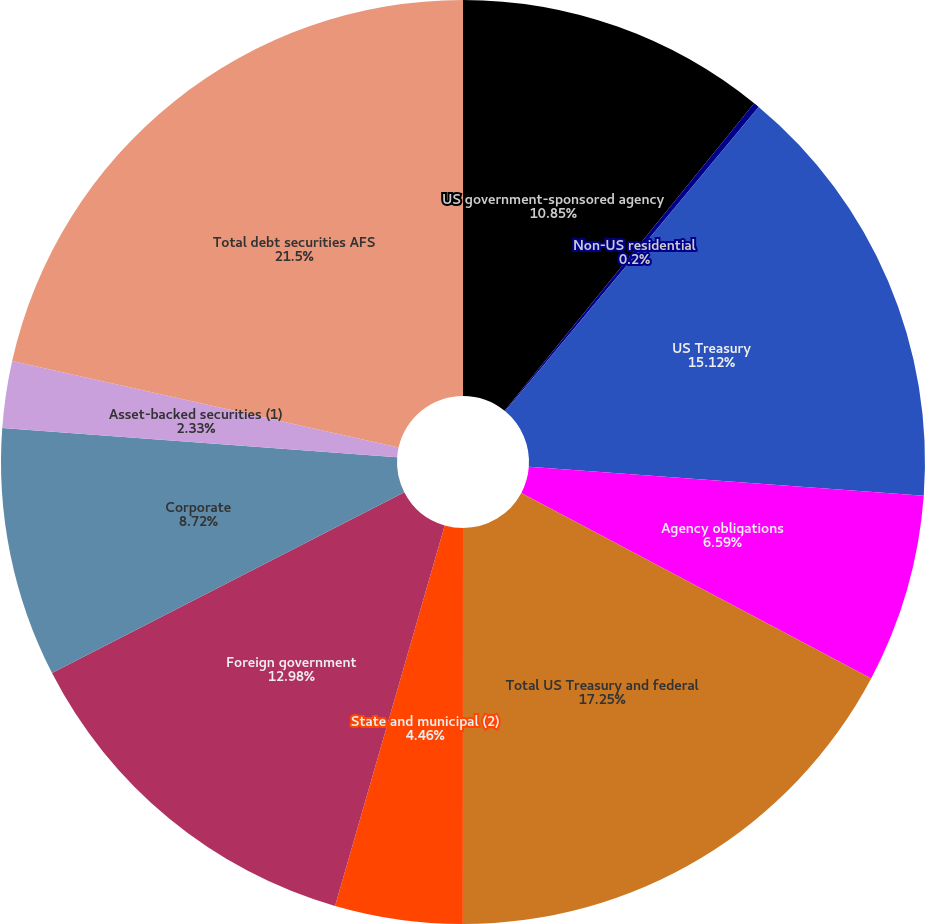Convert chart to OTSL. <chart><loc_0><loc_0><loc_500><loc_500><pie_chart><fcel>US government-sponsored agency<fcel>Non-US residential<fcel>US Treasury<fcel>Agency obligations<fcel>Total US Treasury and federal<fcel>State and municipal (2)<fcel>Foreign government<fcel>Corporate<fcel>Asset-backed securities (1)<fcel>Total debt securities AFS<nl><fcel>10.85%<fcel>0.2%<fcel>15.11%<fcel>6.59%<fcel>17.24%<fcel>4.46%<fcel>12.98%<fcel>8.72%<fcel>2.33%<fcel>21.49%<nl></chart> 